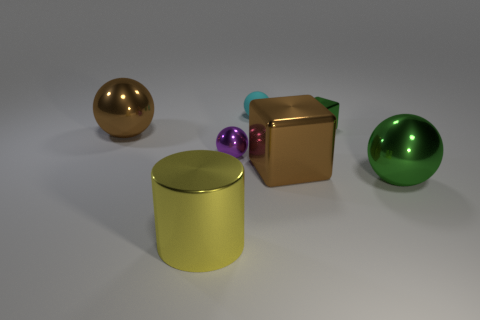What number of other objects are the same color as the tiny metal sphere?
Give a very brief answer. 0. How many yellow things are tiny rubber balls or big cylinders?
Your response must be concise. 1. There is a large green shiny sphere that is in front of the brown metal thing that is to the left of the large brown block; are there any brown things that are in front of it?
Offer a very short reply. No. Is there anything else that is the same size as the yellow thing?
Provide a succinct answer. Yes. The large shiny ball that is to the right of the metallic object in front of the big green ball is what color?
Your response must be concise. Green. What number of small things are metal cylinders or blue metallic balls?
Your answer should be very brief. 0. The thing that is to the right of the tiny cyan thing and behind the brown metallic sphere is what color?
Your response must be concise. Green. Is the material of the green cube the same as the small cyan object?
Provide a succinct answer. No. What is the shape of the yellow shiny thing?
Provide a short and direct response. Cylinder. What number of big cylinders are behind the large sphere that is behind the green metallic sphere in front of the brown shiny sphere?
Provide a short and direct response. 0. 